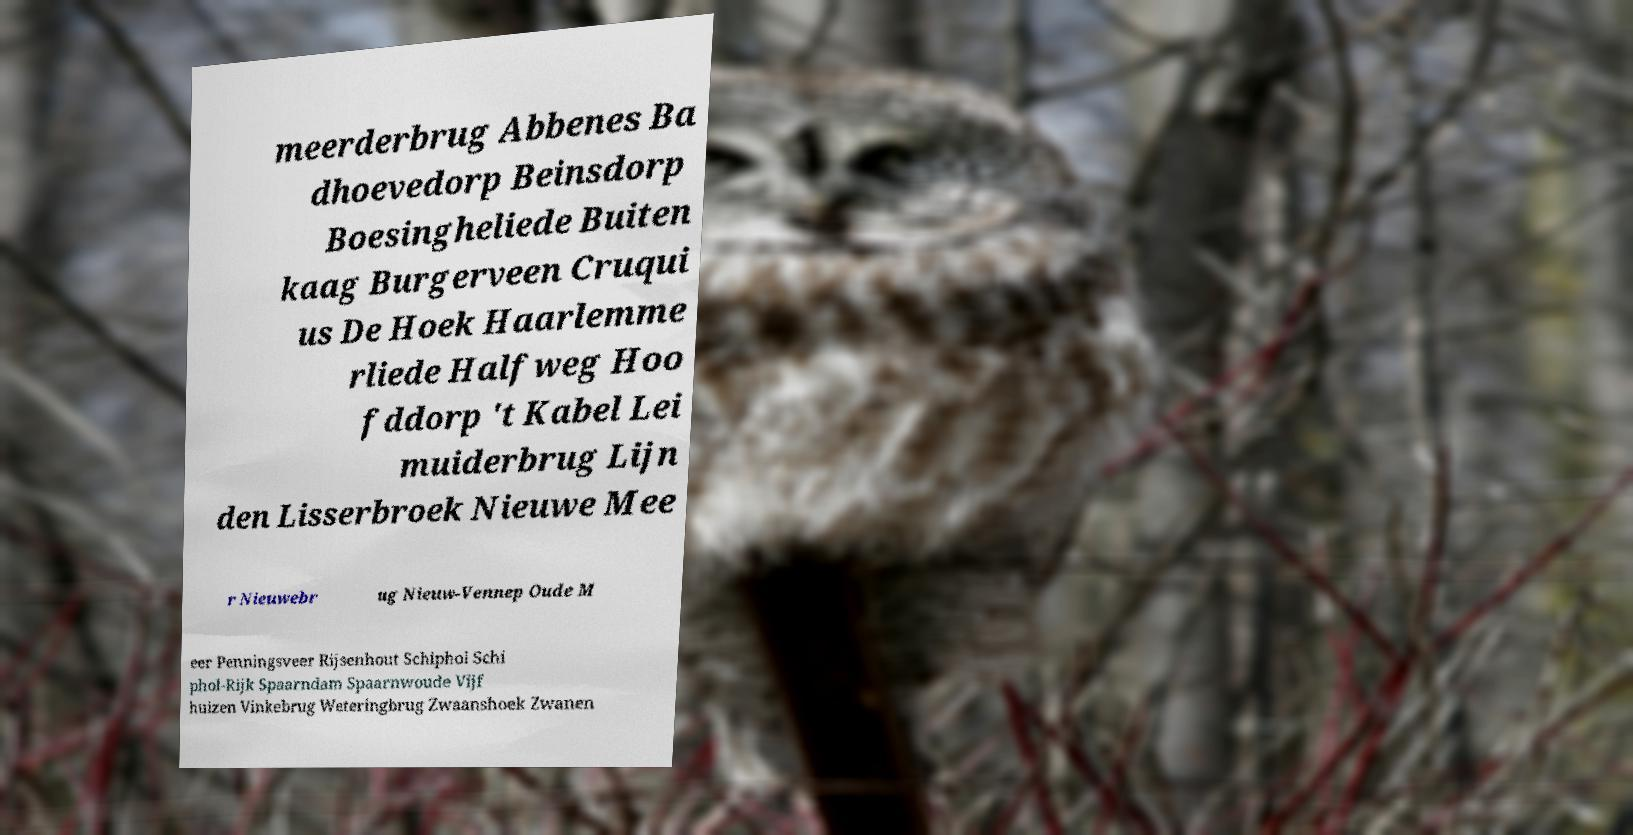I need the written content from this picture converted into text. Can you do that? meerderbrug Abbenes Ba dhoevedorp Beinsdorp Boesingheliede Buiten kaag Burgerveen Cruqui us De Hoek Haarlemme rliede Halfweg Hoo fddorp 't Kabel Lei muiderbrug Lijn den Lisserbroek Nieuwe Mee r Nieuwebr ug Nieuw-Vennep Oude M eer Penningsveer Rijsenhout Schiphol Schi phol-Rijk Spaarndam Spaarnwoude Vijf huizen Vinkebrug Weteringbrug Zwaanshoek Zwanen 